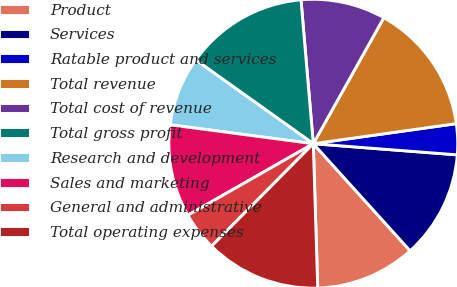<chart> <loc_0><loc_0><loc_500><loc_500><pie_chart><fcel>Product<fcel>Services<fcel>Ratable product and services<fcel>Total revenue<fcel>Total cost of revenue<fcel>Total gross profit<fcel>Research and development<fcel>Sales and marketing<fcel>General and administrative<fcel>Total operating expenses<nl><fcel>11.21%<fcel>12.07%<fcel>3.45%<fcel>14.66%<fcel>9.48%<fcel>13.79%<fcel>7.76%<fcel>10.34%<fcel>4.31%<fcel>12.93%<nl></chart> 